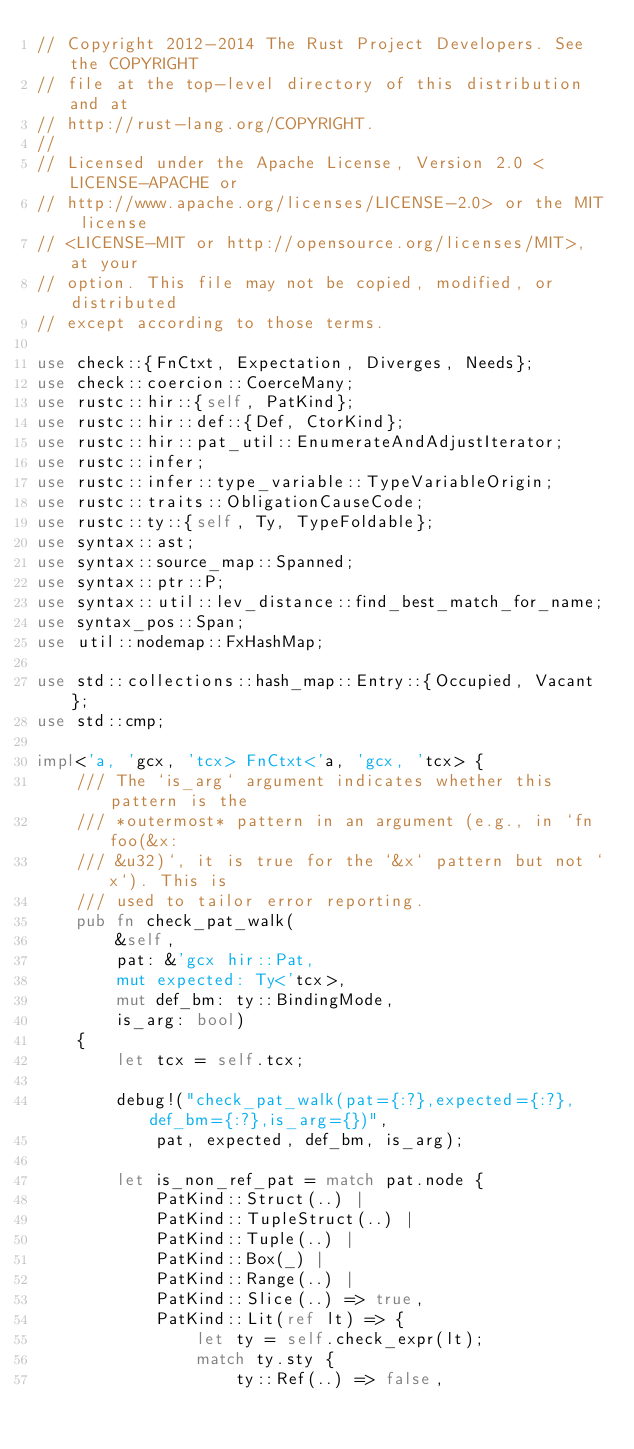Convert code to text. <code><loc_0><loc_0><loc_500><loc_500><_Rust_>// Copyright 2012-2014 The Rust Project Developers. See the COPYRIGHT
// file at the top-level directory of this distribution and at
// http://rust-lang.org/COPYRIGHT.
//
// Licensed under the Apache License, Version 2.0 <LICENSE-APACHE or
// http://www.apache.org/licenses/LICENSE-2.0> or the MIT license
// <LICENSE-MIT or http://opensource.org/licenses/MIT>, at your
// option. This file may not be copied, modified, or distributed
// except according to those terms.

use check::{FnCtxt, Expectation, Diverges, Needs};
use check::coercion::CoerceMany;
use rustc::hir::{self, PatKind};
use rustc::hir::def::{Def, CtorKind};
use rustc::hir::pat_util::EnumerateAndAdjustIterator;
use rustc::infer;
use rustc::infer::type_variable::TypeVariableOrigin;
use rustc::traits::ObligationCauseCode;
use rustc::ty::{self, Ty, TypeFoldable};
use syntax::ast;
use syntax::source_map::Spanned;
use syntax::ptr::P;
use syntax::util::lev_distance::find_best_match_for_name;
use syntax_pos::Span;
use util::nodemap::FxHashMap;

use std::collections::hash_map::Entry::{Occupied, Vacant};
use std::cmp;

impl<'a, 'gcx, 'tcx> FnCtxt<'a, 'gcx, 'tcx> {
    /// The `is_arg` argument indicates whether this pattern is the
    /// *outermost* pattern in an argument (e.g., in `fn foo(&x:
    /// &u32)`, it is true for the `&x` pattern but not `x`). This is
    /// used to tailor error reporting.
    pub fn check_pat_walk(
        &self,
        pat: &'gcx hir::Pat,
        mut expected: Ty<'tcx>,
        mut def_bm: ty::BindingMode,
        is_arg: bool)
    {
        let tcx = self.tcx;

        debug!("check_pat_walk(pat={:?},expected={:?},def_bm={:?},is_arg={})",
            pat, expected, def_bm, is_arg);

        let is_non_ref_pat = match pat.node {
            PatKind::Struct(..) |
            PatKind::TupleStruct(..) |
            PatKind::Tuple(..) |
            PatKind::Box(_) |
            PatKind::Range(..) |
            PatKind::Slice(..) => true,
            PatKind::Lit(ref lt) => {
                let ty = self.check_expr(lt);
                match ty.sty {
                    ty::Ref(..) => false,</code> 